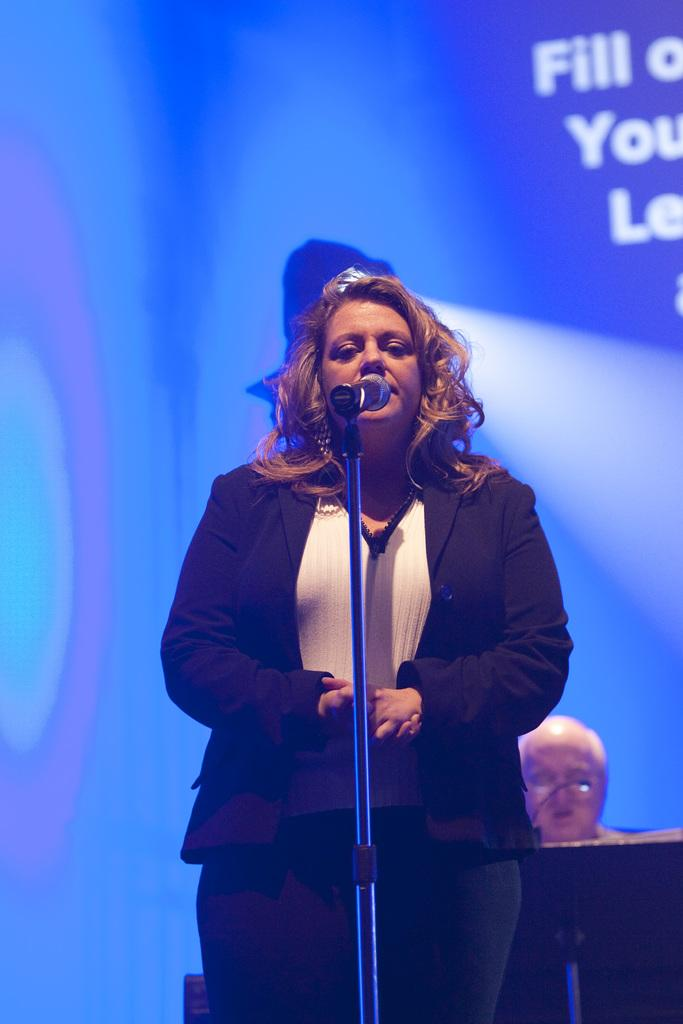Who is the main subject in the image? There is a woman in the image. What is the woman doing in the image? The woman is standing in the image. What is the woman wearing? The woman is wearing a black and white dress. What is in front of the woman? There is a mic and a stand in front of the woman. What color is the background of the image? The background of the image is blue. Is there any text or writing visible in the image? Yes, there is text or writing on the background. What type of spade is the woman using to dig in the image? There is no spade present in the image; the woman is standing with a mic and a stand in front of her. What design is the woman creating with the mic in the image? The image does not depict the woman creating any design with the mic; she is simply standing with it in front of her. 